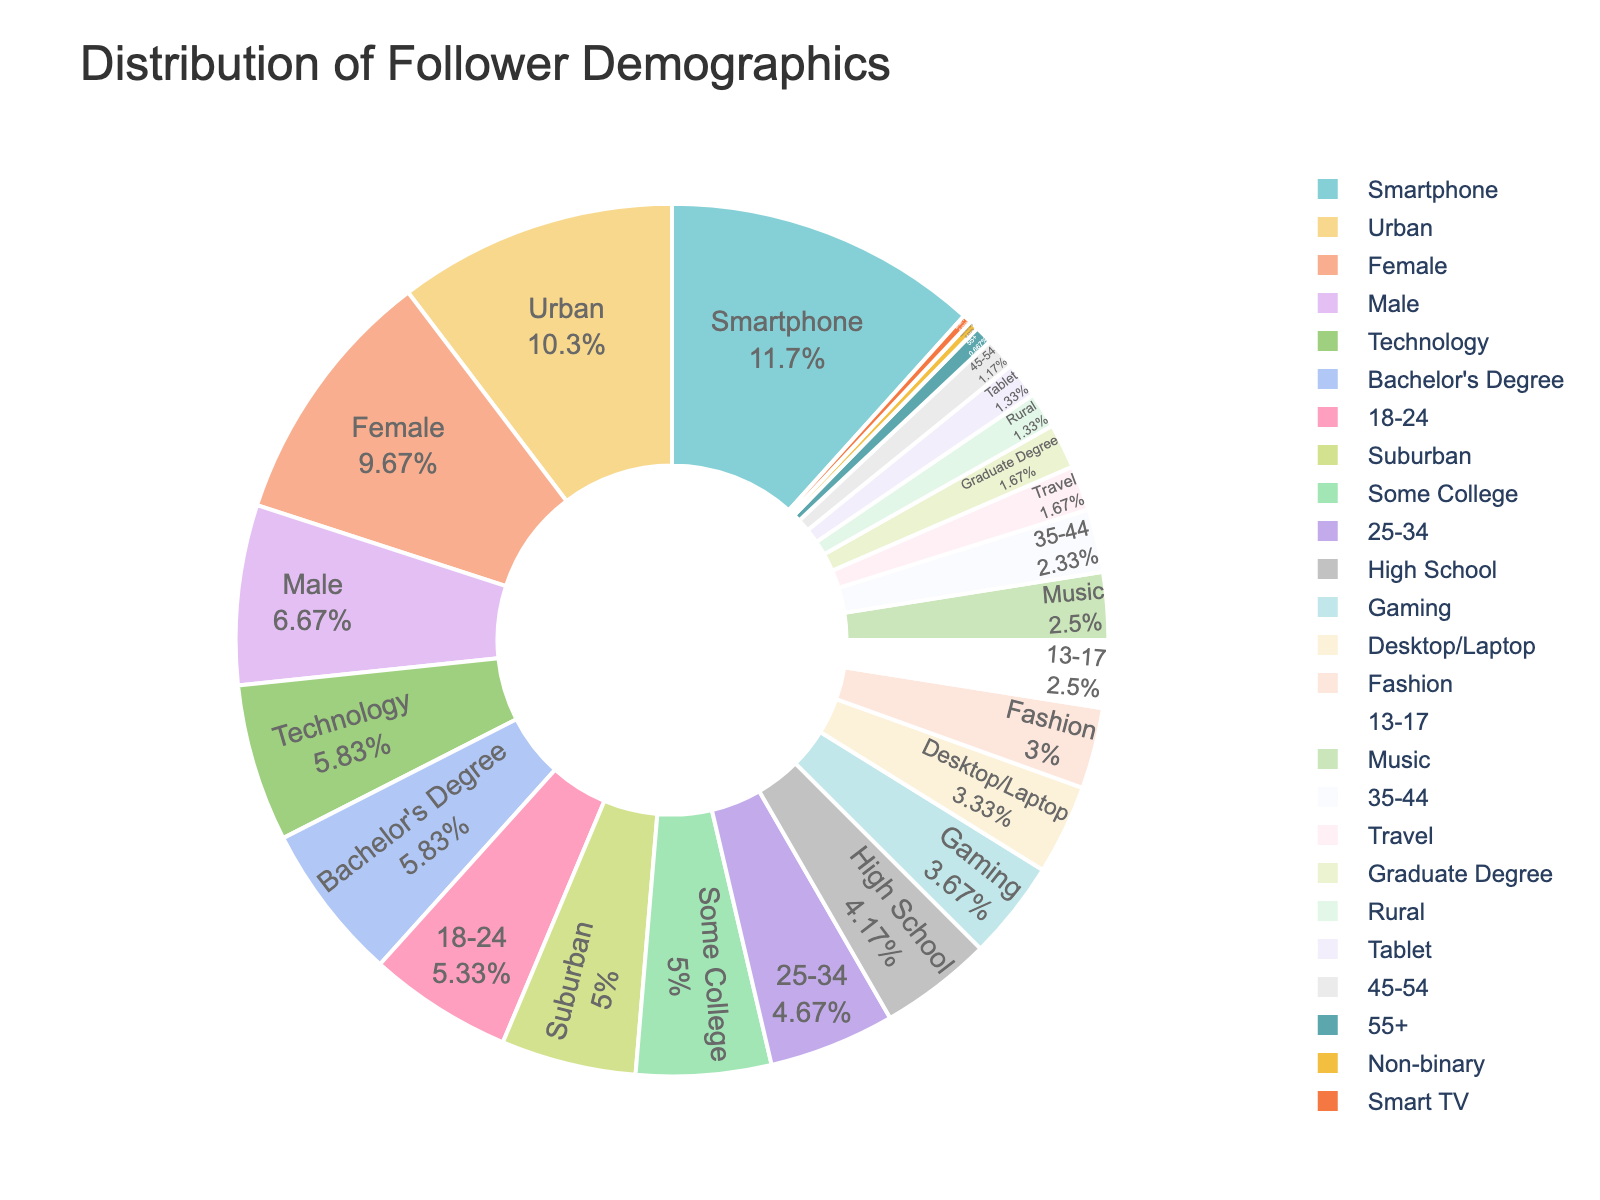Which age group constitutes the largest percentage of followers? To find the largest age group, observe the pie chart and locate the slice with the highest percentage.
Answer: 18-24 How much larger is the percentage of followers aged 18-24 compared to those aged 55+? Identify the percentages for both age groups from the pie chart: 18-24 is 32%, and 55+ is 4%. Subtract the smaller percentage from the larger one: 32% - 4% = 28%.
Answer: 28% What is the combined percentage of followers aged 13-24? Find the percentages for both age groups, 13-17 (15%) and 18-24 (32%). Add them together: 15% + 32% = 47%.
Answer: 47% Which gender has the highest representation among followers? Locate the gender slices and identify the one with the largest percentage.
Answer: Female By how much does the percentage of male followers exceed that of non-binary followers? Find the percentages for male (40%) and non-binary (2%) followers from the pie chart. Subtract the smaller percentage from the larger one: 40% - 2% = 38%.
Answer: 38% Which demographic aspect shows the least variability in follower distribution? Review the segments for different demographic aspects such as device usage, location, interests, etc., and determine which one has percentage values closest to each other.
Answer: Device Usage Which interest category has the smallest percentage of followers? Observe the pie chart and find the slice with the lowest percentage under interests.
Answer: Travel How does the percentage of urban followers compare to suburban followers? Identify the percentages for both locations: Urban (62%) and Suburban (30%). State the comparison clearly: 62% is greater than 30%.
Answer: Urban is greater What is the median age group percentage? List the age group percentages: 4%, 7%, 14%, 15%, 28%, 32%. With six numbers, the median will be the average of the third and fourth numbers: (14% + 15%) / 2 = 14.5%.
Answer: 14.5% Which device category has the smallest representation among followers? Find and identify the slice with the lowest percentage from the device usage segments.
Answer: Smart TV 